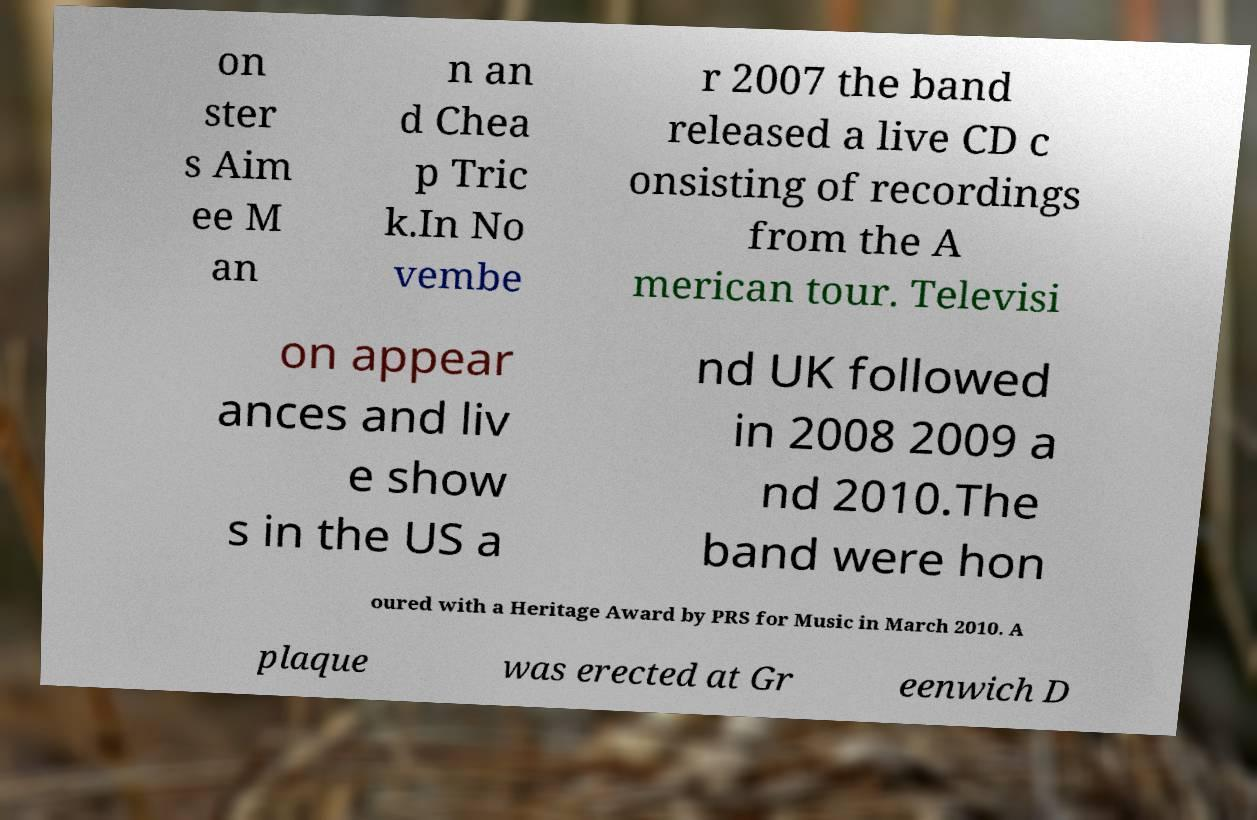Could you extract and type out the text from this image? on ster s Aim ee M an n an d Chea p Tric k.In No vembe r 2007 the band released a live CD c onsisting of recordings from the A merican tour. Televisi on appear ances and liv e show s in the US a nd UK followed in 2008 2009 a nd 2010.The band were hon oured with a Heritage Award by PRS for Music in March 2010. A plaque was erected at Gr eenwich D 